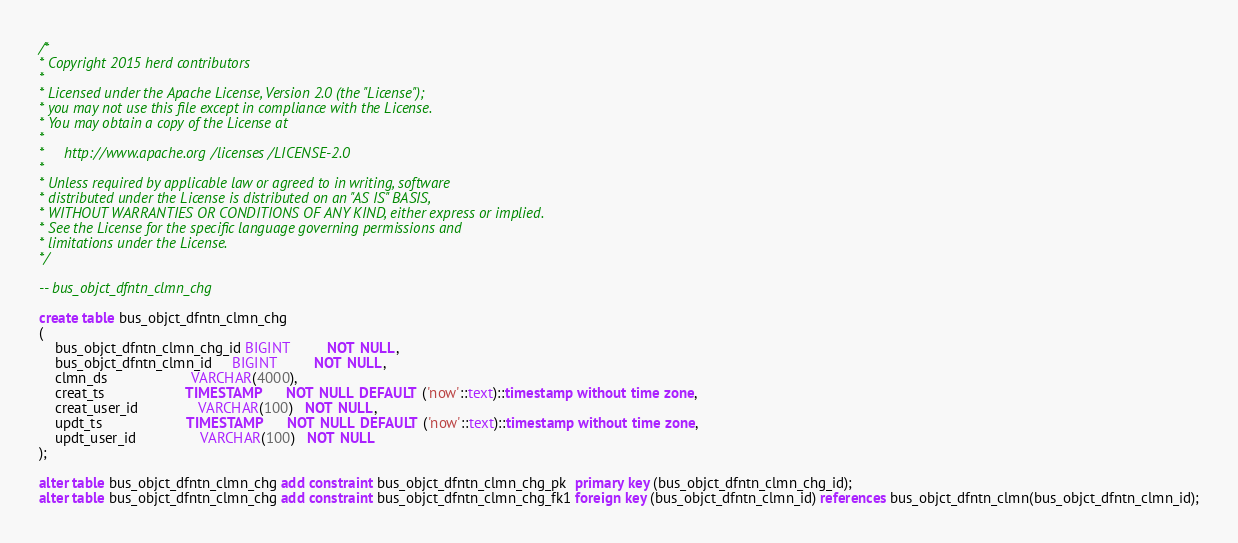Convert code to text. <code><loc_0><loc_0><loc_500><loc_500><_SQL_>/*
* Copyright 2015 herd contributors
*
* Licensed under the Apache License, Version 2.0 (the "License");
* you may not use this file except in compliance with the License.
* You may obtain a copy of the License at
*
*     http://www.apache.org/licenses/LICENSE-2.0
*
* Unless required by applicable law or agreed to in writing, software
* distributed under the License is distributed on an "AS IS" BASIS,
* WITHOUT WARRANTIES OR CONDITIONS OF ANY KIND, either express or implied.
* See the License for the specific language governing permissions and
* limitations under the License.
*/

-- bus_objct_dfntn_clmn_chg

create table bus_objct_dfntn_clmn_chg
(
    bus_objct_dfntn_clmn_chg_id BIGINT         NOT NULL,
    bus_objct_dfntn_clmn_id     BIGINT         NOT NULL,
    clmn_ds                     VARCHAR(4000),
    creat_ts                    TIMESTAMP      NOT NULL DEFAULT ('now'::text)::timestamp without time zone,
    creat_user_id               VARCHAR(100)   NOT NULL,
    updt_ts                     TIMESTAMP      NOT NULL DEFAULT ('now'::text)::timestamp without time zone,
    updt_user_id                VARCHAR(100)   NOT NULL
);

alter table bus_objct_dfntn_clmn_chg add constraint bus_objct_dfntn_clmn_chg_pk  primary key (bus_objct_dfntn_clmn_chg_id); 
alter table bus_objct_dfntn_clmn_chg add constraint bus_objct_dfntn_clmn_chg_fk1 foreign key (bus_objct_dfntn_clmn_id) references bus_objct_dfntn_clmn(bus_objct_dfntn_clmn_id);
</code> 